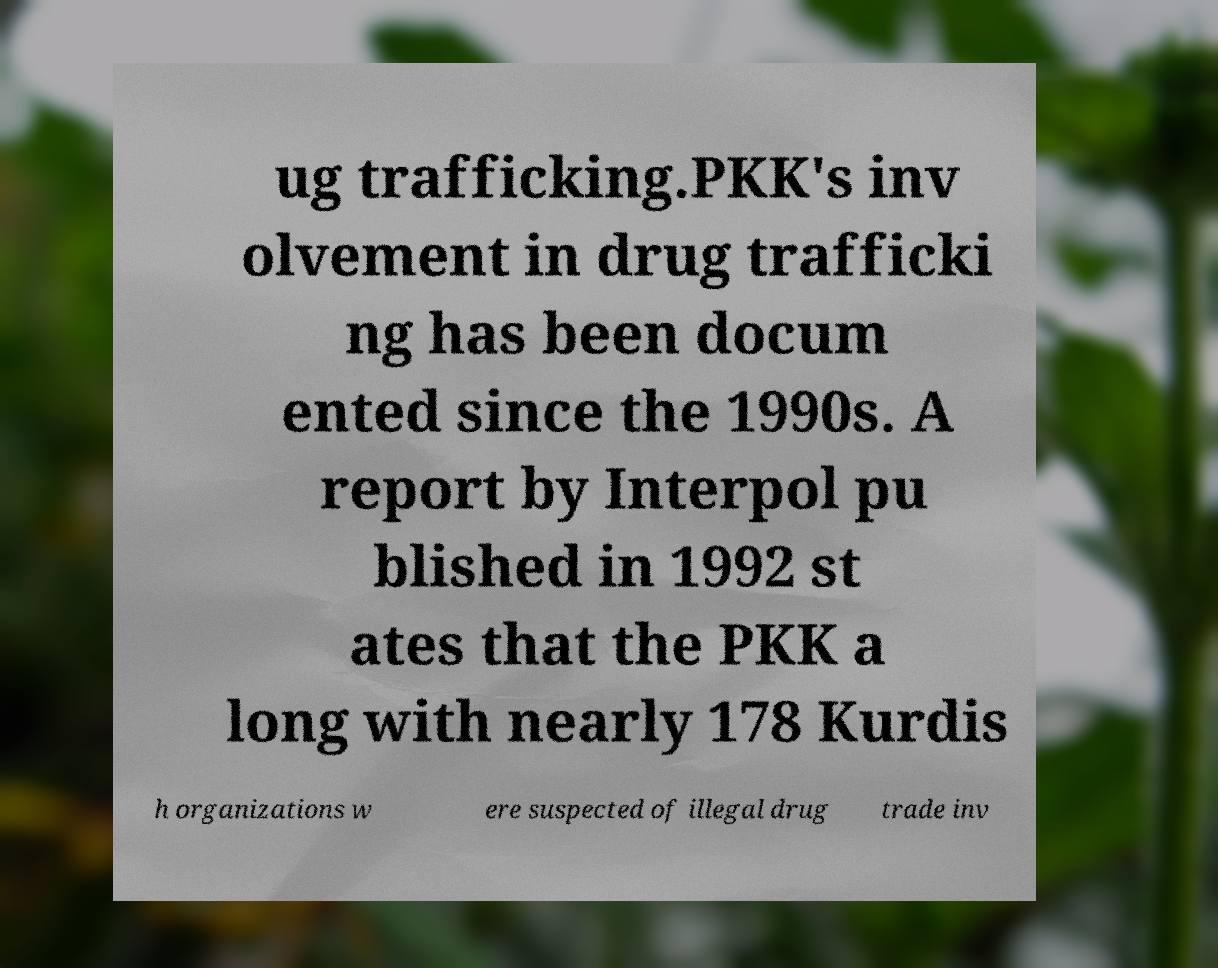Could you extract and type out the text from this image? ug trafficking.PKK's inv olvement in drug trafficki ng has been docum ented since the 1990s. A report by Interpol pu blished in 1992 st ates that the PKK a long with nearly 178 Kurdis h organizations w ere suspected of illegal drug trade inv 